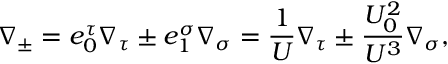Convert formula to latex. <formula><loc_0><loc_0><loc_500><loc_500>\nabla _ { \pm } = e _ { 0 } ^ { \tau } \nabla _ { \tau } \pm e _ { 1 } ^ { \sigma } \nabla _ { \sigma } = \frac { 1 } { U } \nabla _ { \tau } \pm \frac { U _ { 0 } ^ { 2 } } { U ^ { 3 } } \nabla _ { \sigma } ,</formula> 